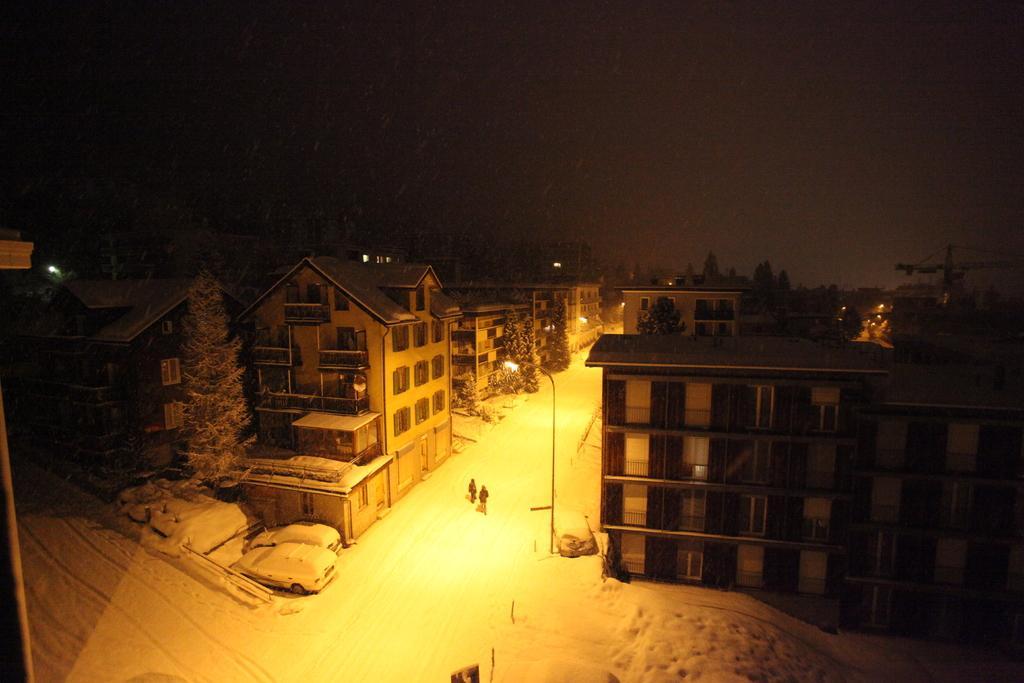Describe this image in one or two sentences. In this image I can see few buildings, windows, trees, light poles, few people and the snow. Background is dark. 